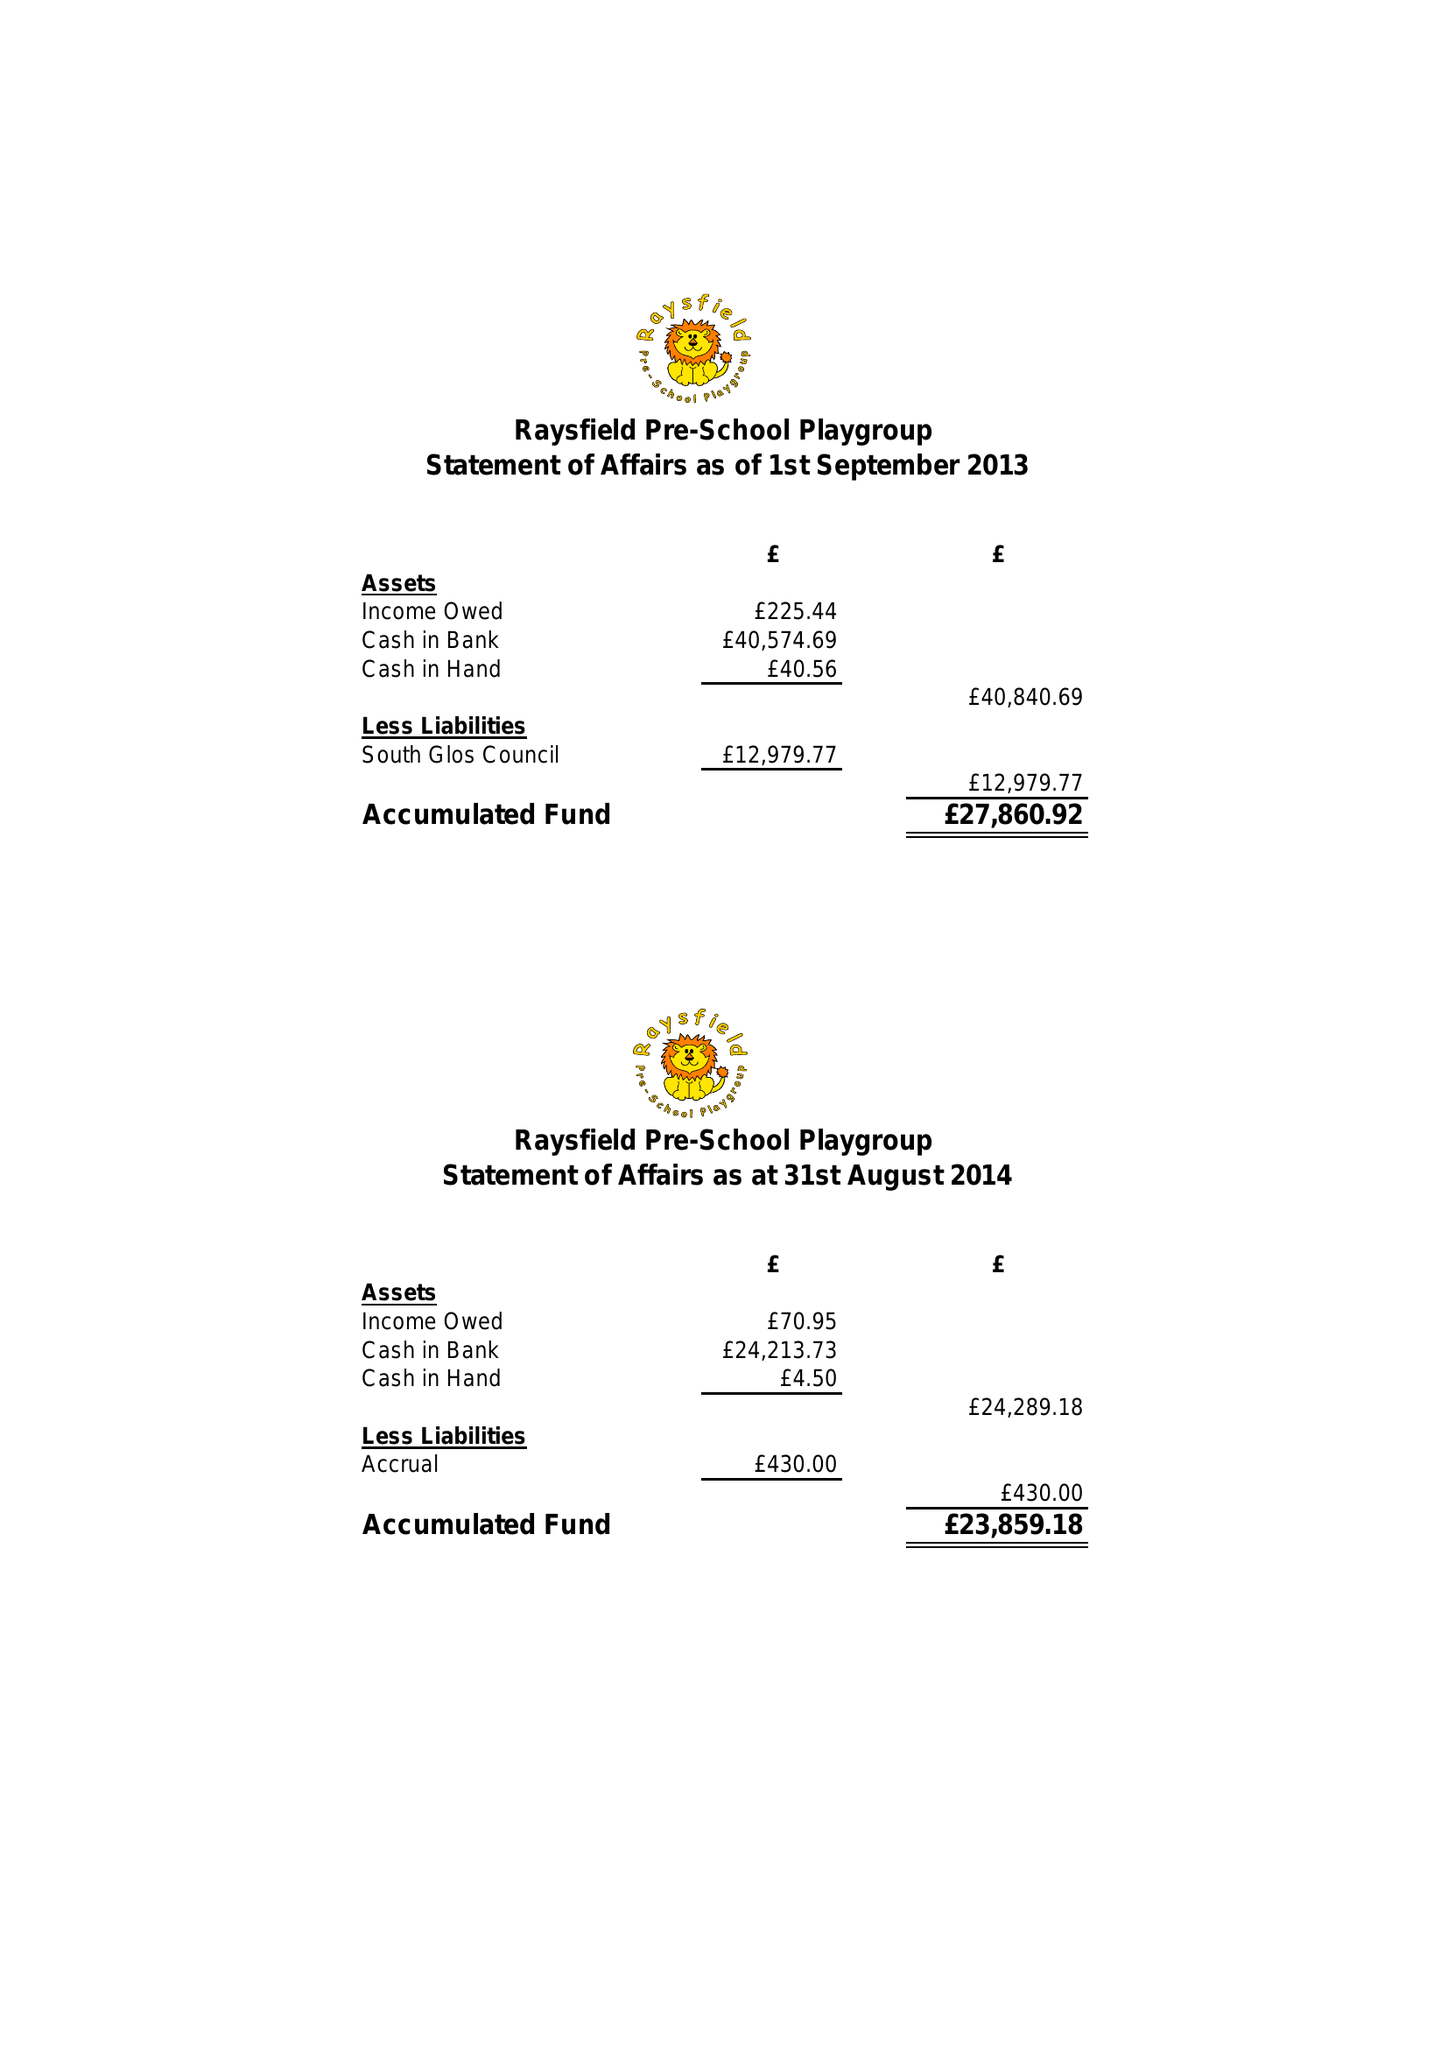What is the value for the charity_name?
Answer the question using a single word or phrase. Raysfield Pre - School 